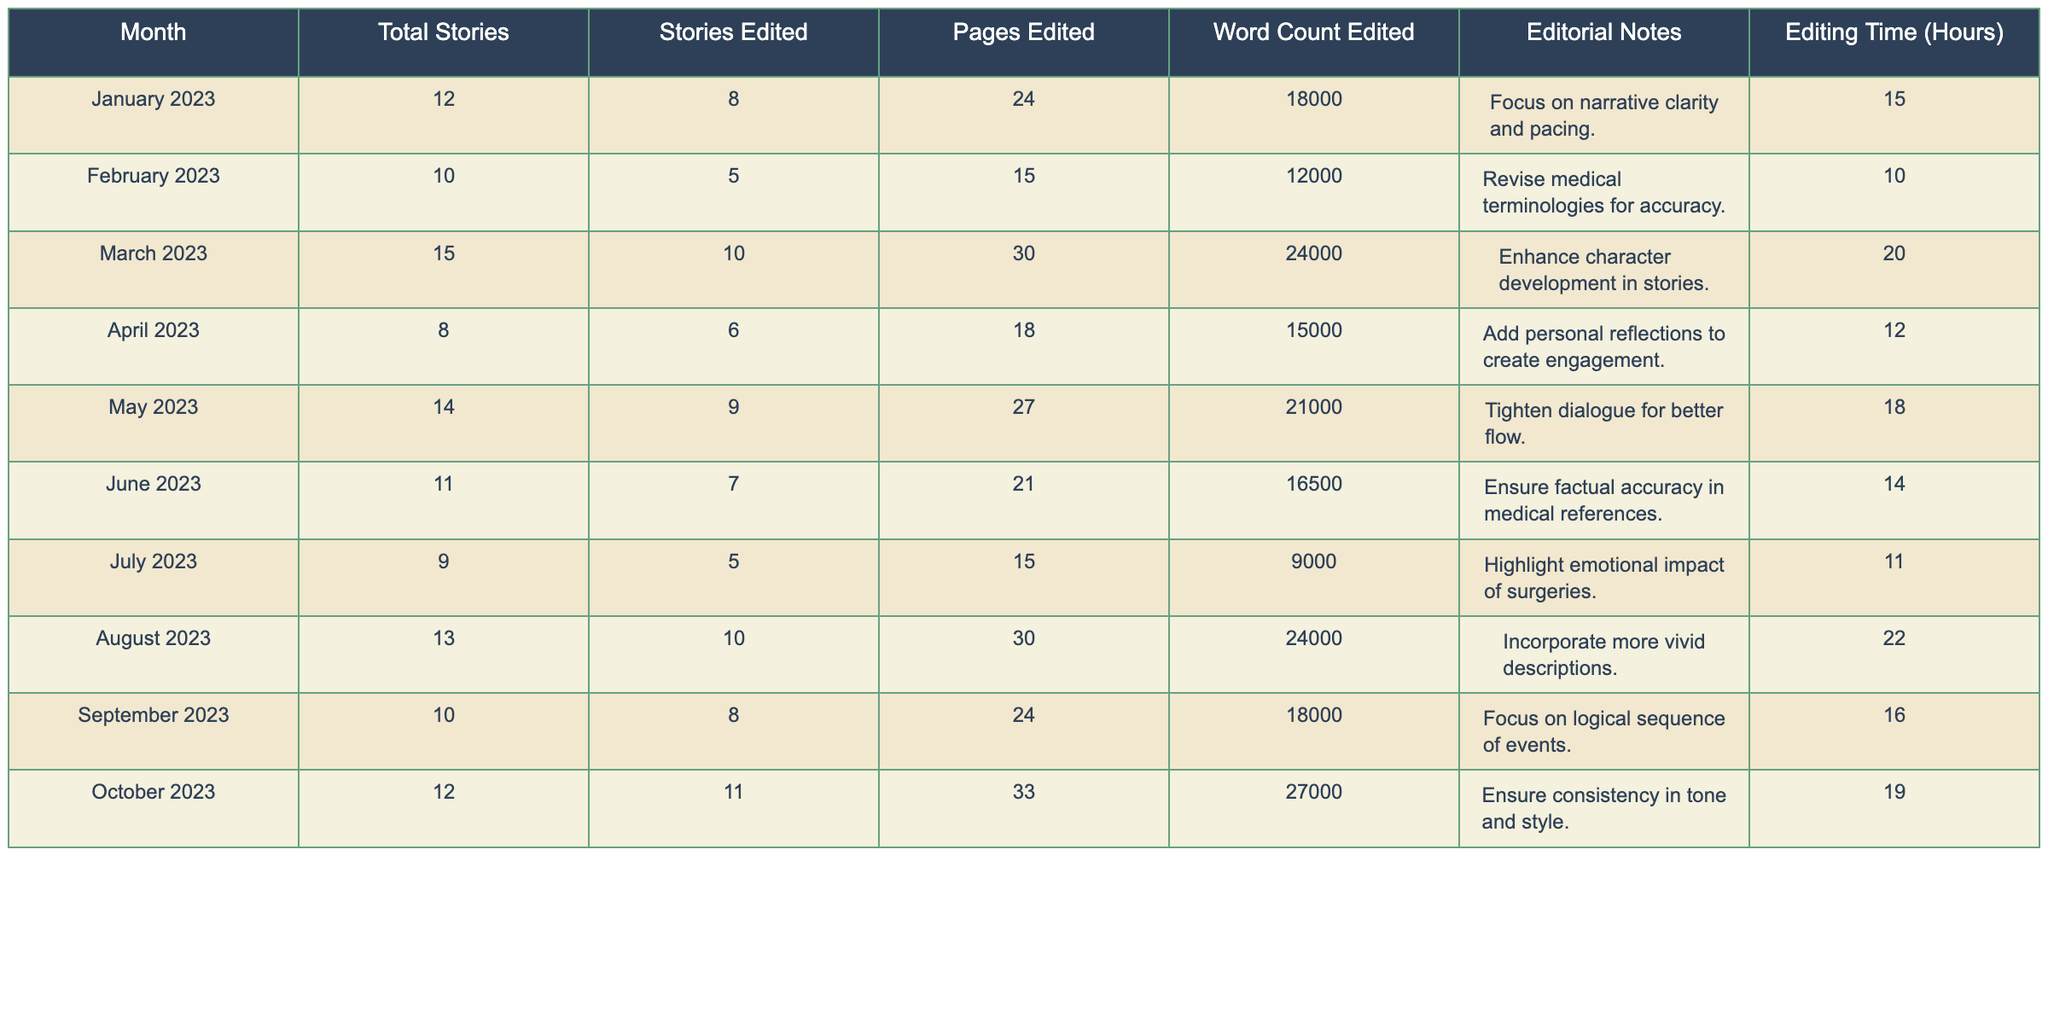What was the total number of stories edited in October 2023? According to the data for October 2023, the number of stories edited is listed directly as 11.
Answer: 11 How many pages were edited in March 2023? The table indicates that in March 2023, the number of pages edited was 30, directly referencing that month's data.
Answer: 30 What is the average word count edited across all months? To find the average, sum the total word counts edited from each month: (18000 + 12000 + 24000 + 15000 + 21000 + 16500 + 9000 + 24000 + 18000 + 27000) = 141500. Then, divide by the number of months (10), resulting in an average of 141500/10 = 14150.
Answer: 14150 Did the editing time in June 2023 exceed 15 hours? The editing time for June 2023 is shown in the table as 14 hours, which is less than 15 hours.
Answer: No Which month had the highest word count edited, and what was that count? By reviewing each month's word count in the table, October 2023 has the highest word count edited of 27000.
Answer: October 2023, 27000 How many total stories were edited from January to August 2023? Adding the stories edited from January (8), February (5), March (10), April (6), May (9), June (7), July (5), and August (10) gives a total of 8 + 5 + 10 + 6 + 9 + 7 + 5 + 10 = 60.
Answer: 60 What percentage of the total stories were edited in September 2023 out of the total stories for that month? In September 2023, 8 stories were edited out of a total of 10 stories. The percentage of stories edited is (8/10)*100 = 80%.
Answer: 80% In which month did the editor spend the most editing time and what was that duration? By checking each month's editing time, August 2023 shows the highest time spent at 22 hours.
Answer: August 2023, 22 hours How many stories were edited more in October than in January? In January, 8 stories were edited, and in October, 11 stories were edited. The difference is 11 - 8 = 3 more stories in October.
Answer: 3 What is the total editing time from January to April 2023? The editing times for January (15), February (10), March (20), and April (12) sum up to 15 + 10 + 20 + 12 = 67 hours.
Answer: 67 hours 